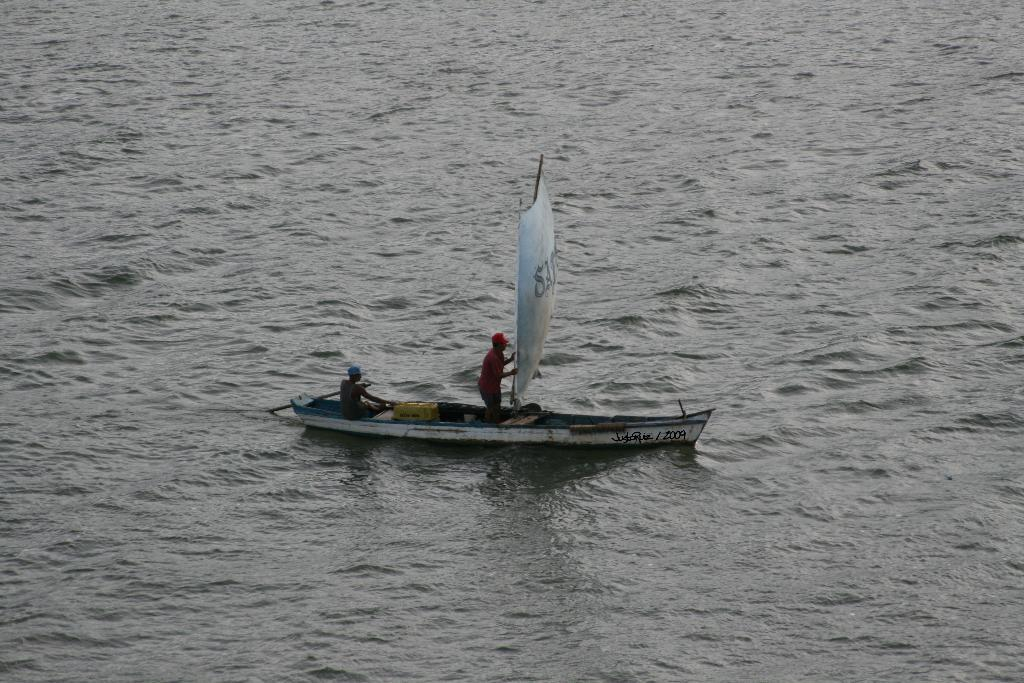What is the main subject of the image? The main subject of the image is a boat. What is the boat doing in the image? The boat is sailing on the water. What feature is present on the boat? There is a sailing cloth on the boat. How many people are in the boat? There are two members in the boat. What can be seen in the background of the image? There is water visible in the background of the image. Where is the box located in the image? There is no box present in the image. Can you see a park in the background of the image? There is no park visible in the image; only water is present in the background. 